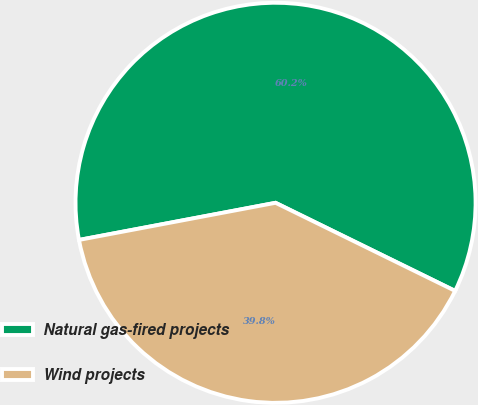Convert chart. <chart><loc_0><loc_0><loc_500><loc_500><pie_chart><fcel>Natural gas-fired projects<fcel>Wind projects<nl><fcel>60.23%<fcel>39.77%<nl></chart> 